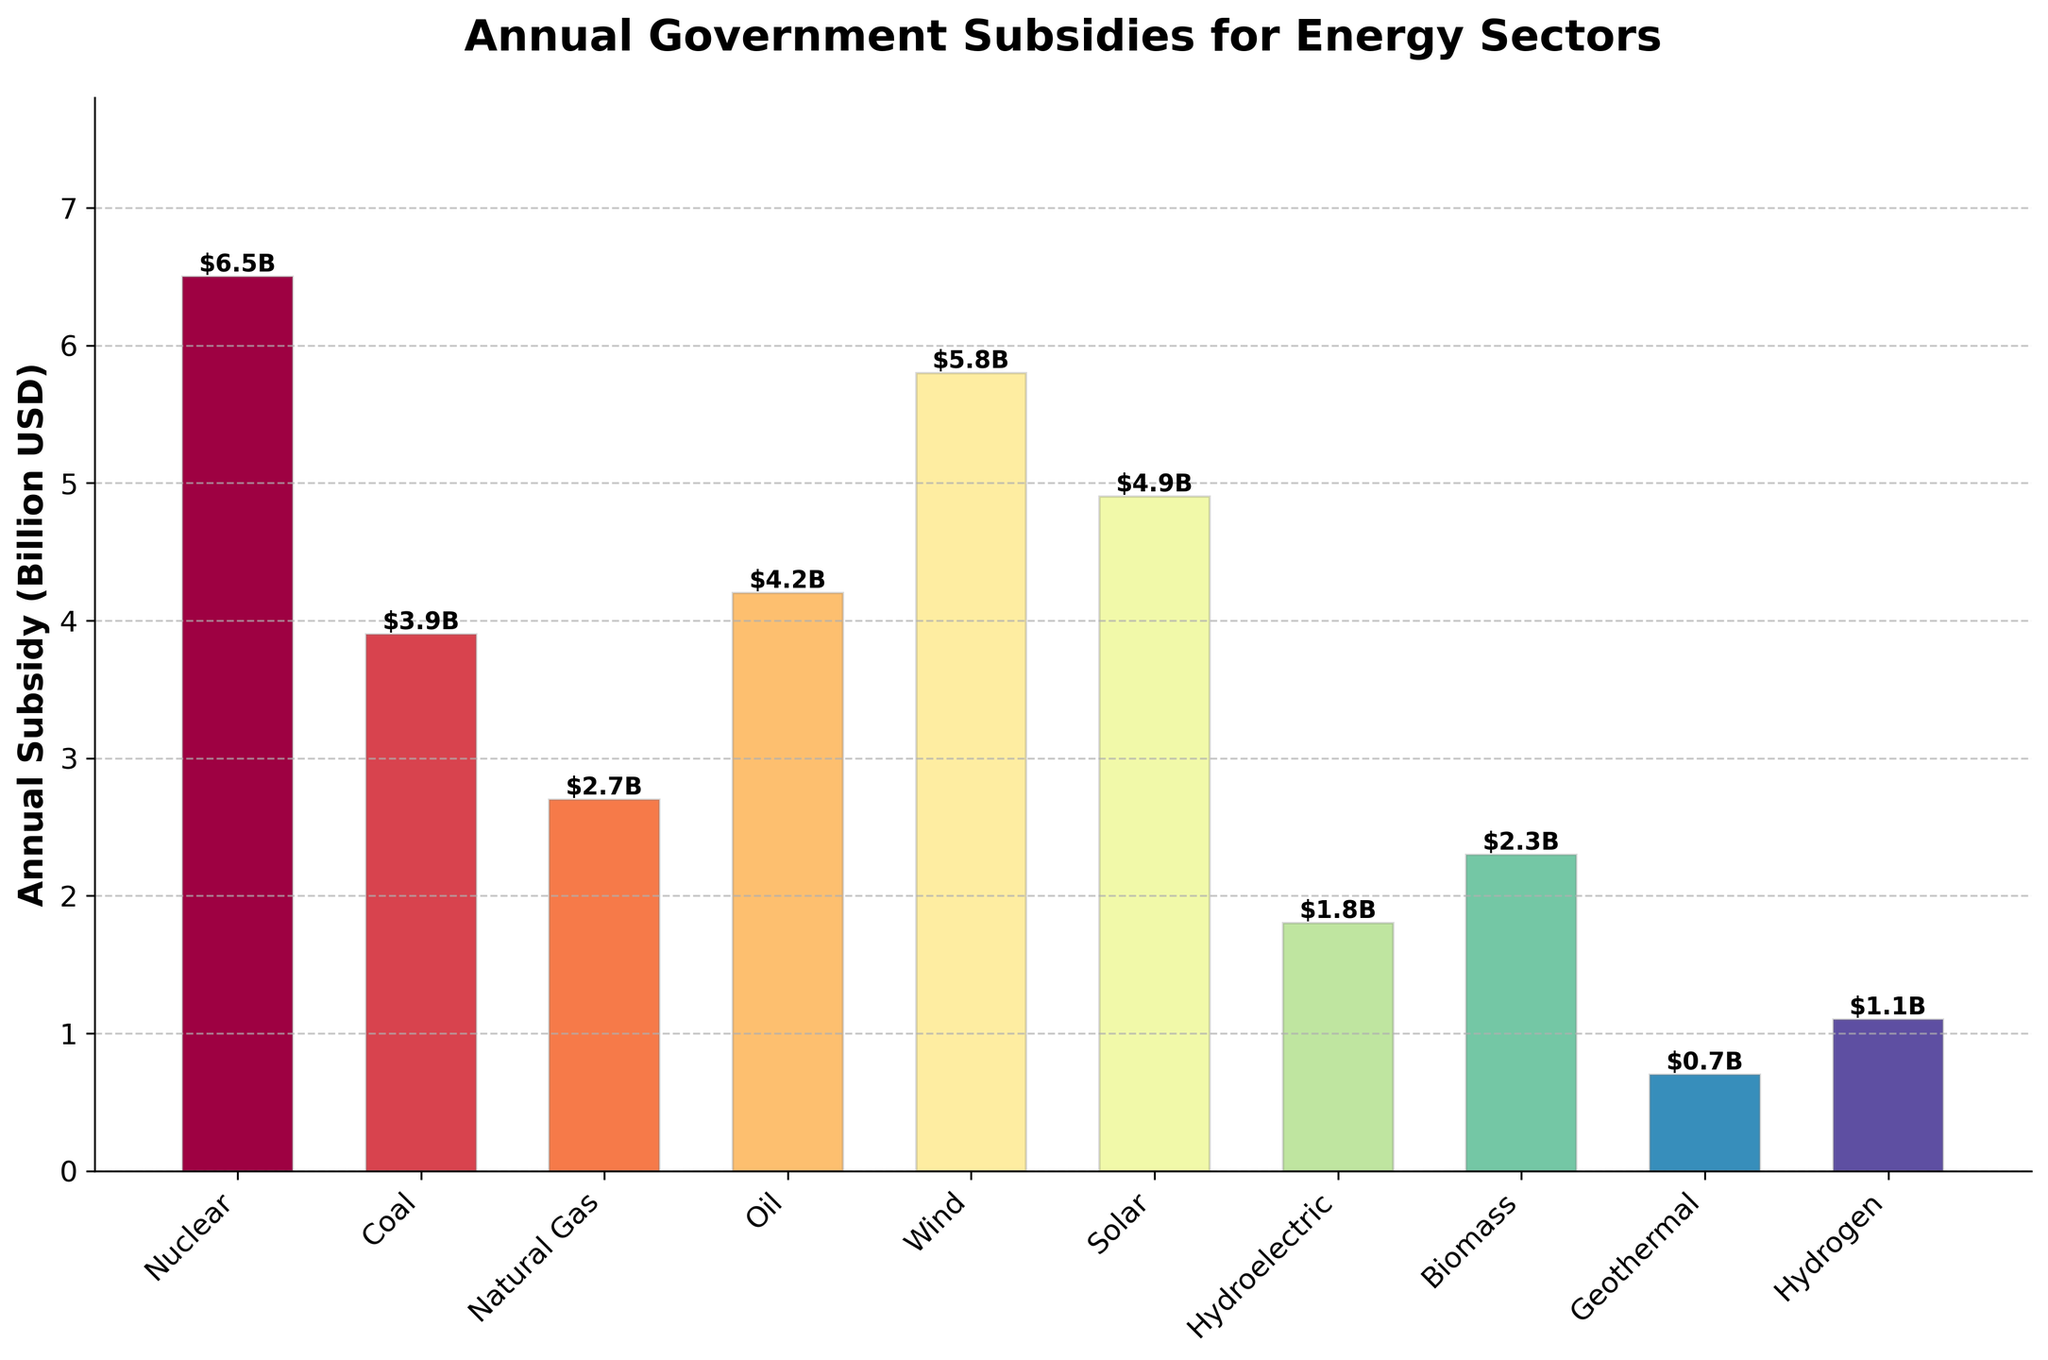What is the total annual subsidy for Nuclear and Solar energy sectors? To find the total, add the annual subsidies for Nuclear and Solar sectors: $6.5B (Nuclear) + $4.9B (Solar) = $11.4B
Answer: $11.4B Which energy sector receives the highest annual subsidy? By comparing the heights of the bars, Wind energy has the highest bar representing an annual subsidy of $5.8B
Answer: Wind How much more subsidy does the Nuclear sector receive compared to the Coal sector? Subtract the annual subsidy of the Coal sector from the Nuclear sector: $6.5B (Nuclear) - $3.9B (Coal) = $2.6B
Answer: $2.6B Which energy sectors have an annual subsidy lower than $2 billion? Observe the bars lower than $2 billion on the y-axis: Hydroelectric ($1.8B), Geothermal ($0.7B), and Hydrogen ($1.1B)
Answer: Hydroelectric, Geothermal, Hydrogen By how much does the annual subsidy for Wind exceed that of Oil? Subtract the annual subsidy of the Oil sector from the Wind sector: $5.8B (Wind) - $4.2B (Oil) = $1.6B
Answer: $1.6B What is the average annual subsidy for the Renewable energy sectors (Wind, Solar, Hydroelectric, Biomass, Geothermal, Hydrogen)? Sum the subsidies for these sectors and divide by the number of sectors: ($5.8B + $4.9B + $1.8B + $2.3B + $0.7B + $1.1B) / 6 = $16.6B / 6 ≈ $2.77B
Answer: $2.77B Which energy sector has the lowest annual subsidy and what is its value? The shortest bar representing the lowest subsidy is for Geothermal, with an annual subsidy of $0.7B
Answer: Geothermal, $0.7B How many energy sectors receive an annual subsidy of more than $5 billion? Count the bars that are higher than $5 billion on the y-axis; they are Wind and Nuclear
Answer: 2 What is the combined annual subsidy for Fossil fuel sectors (Coal, Natural Gas, Oil)? Sum the subsidies for these sectors: $3.9B (Coal) + $2.7B (Natural Gas) + $4.2B (Oil) = $10.8B
Answer: $10.8B How does the annual subsidy for Biomass compare to that of Natural Gas? By comparing the two bars, Biomass ($2.3B) receives slightly less subsidy than Natural Gas ($2.7B)
Answer: Biomass receives less 